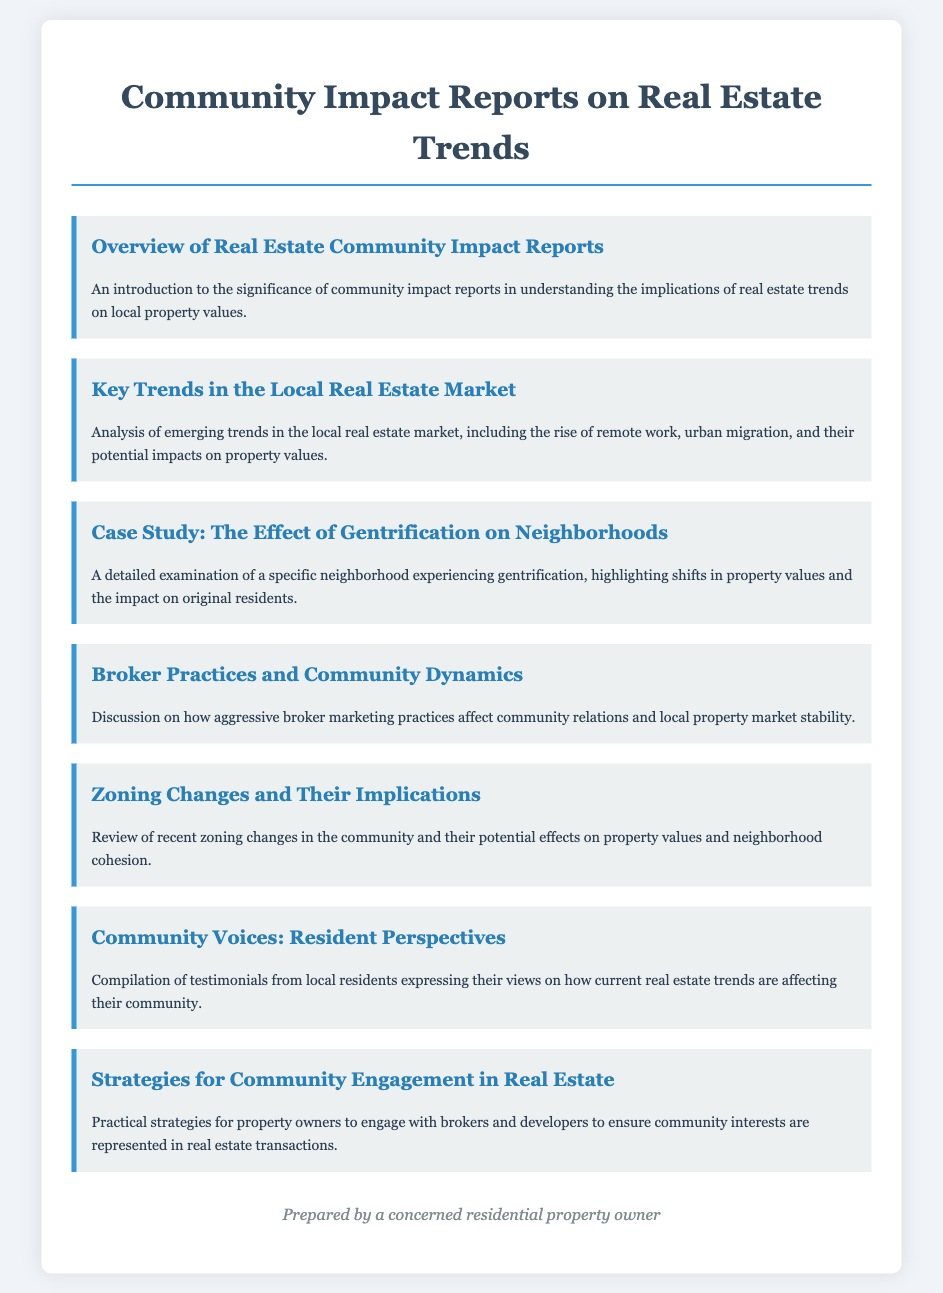What is the title of the document? The title of the document is specified in the head section of the HTML and serves as the main heading on the page.
Answer: Community Impact Reports on Real Estate Trends What are the contents of the first menu item? The first menu item provides an introduction and significance of community impact reports related to real estate trends.
Answer: An introduction to the significance of community impact reports in understanding the implications of real estate trends on local property values How many menu items are there in total? The number of menu items can be counted directly from the structure of the document.
Answer: Seven What is the focus of the "Broker Practices and Community Dynamics" section? This section discusses the ways aggressive broker marketing practices influence community relations and stability in property markets.
Answer: How aggressive broker marketing practices affect community relations and local property market stability What does the "Key Trends in the Local Real Estate Market" section analyze? This section looks at emerging local real estate trends, including the rise of remote work and urban migration.
Answer: Analysis of emerging trends in the local real estate market, including the rise of remote work, urban migration, and their potential impacts on property values What is the purpose of the "Community Voices: Resident Perspectives" section? The section compiles testimonials from local residents regarding the impact of real estate trends on their community.
Answer: Compilation of testimonials from local residents expressing their views on how current real estate trends are affecting their community What key topic does "Zoning Changes and Their Implications" address? This item reviews recent changes in zoning laws and their consequences for property values and community cohesion.
Answer: Review of recent zoning changes in the community and their potential effects on property values and neighborhood cohesion 